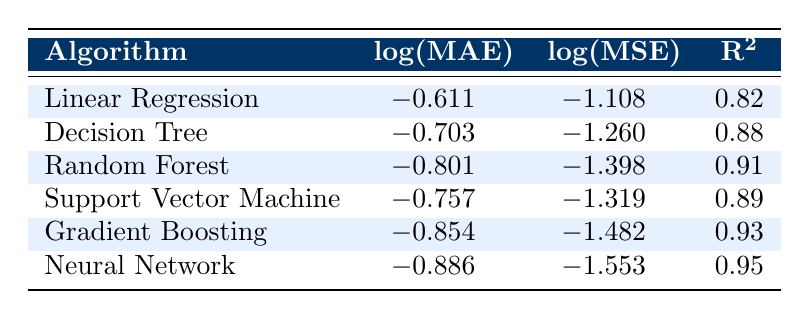What is the log(MAE) value for the Neural Network model? The table lists the log(MAE) values for different algorithms. For the Neural Network model, the corresponding value in the table shows -0.886.
Answer: -0.886 Which algorithm has the lowest log(MSE)? By looking at the log(MSE) column in the table, the lowest value is -1.553 for the Neural Network model, indicating the best mean squared error performance.
Answer: Neural Network Is the R² value for Gradient Boosting greater than 0.90? The R² value for Gradient Boosting is displayed as 0.93 in the table, which is indeed greater than 0.90.
Answer: Yes What is the difference in log(MAE) between Random Forest and Decision Tree? The log(MAE) for Random Forest is -0.801, and for Decision Tree it is -0.703. The difference is calculated by subtracting the two values: -0.801 - (-0.703) = -0.098.
Answer: -0.098 Which algorithm has the highest R² value? By examining the R² column in the table, the Neural Network has the highest value at 0.95, indicating it has the best explanatory power among the models listed.
Answer: Neural Network What is the average log(MSE) for all the algorithms? To find the average, sum the log(MSE) values: (-1.108) + (-1.260) + (-1.398) + (-1.319) + (-1.482) + (-1.553) = -8.120. There are 6 algorithms, so the average is -8.120 / 6 = -1.3533.
Answer: -1.3533 Is the R² value of the Support Vector Machine model above 0.85? The R² value listed for the Support Vector Machine is 0.89, which is above 0.85.
Answer: Yes What is the range of log(MAE) values across all models? The log(MAE) values range from -0.611 (Linear Regression) to -0.886 (Neural Network). To find the range: -0.886 - (-0.611) = -0.275.
Answer: -0.275 